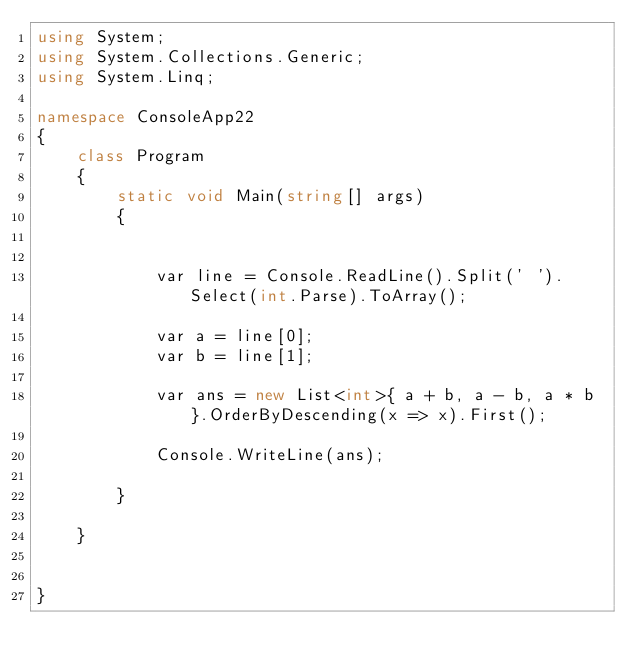Convert code to text. <code><loc_0><loc_0><loc_500><loc_500><_C#_>using System;
using System.Collections.Generic;
using System.Linq;

namespace ConsoleApp22
{
    class Program
    {
        static void Main(string[] args)
        {


            var line = Console.ReadLine().Split(' ').Select(int.Parse).ToArray();

            var a = line[0];
            var b = line[1];

            var ans = new List<int>{ a + b, a - b, a * b }.OrderByDescending(x => x).First();

            Console.WriteLine(ans);

        }

    }


}
</code> 